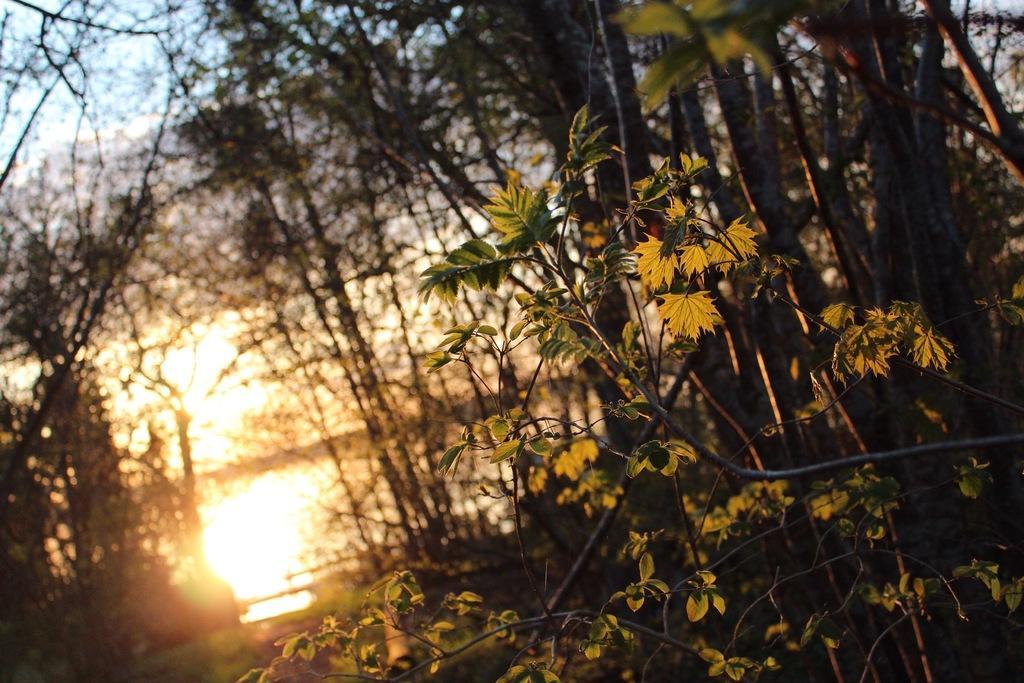How would you summarize this image in a sentence or two? In this picture we can see trees and in the background we can see the sky. 